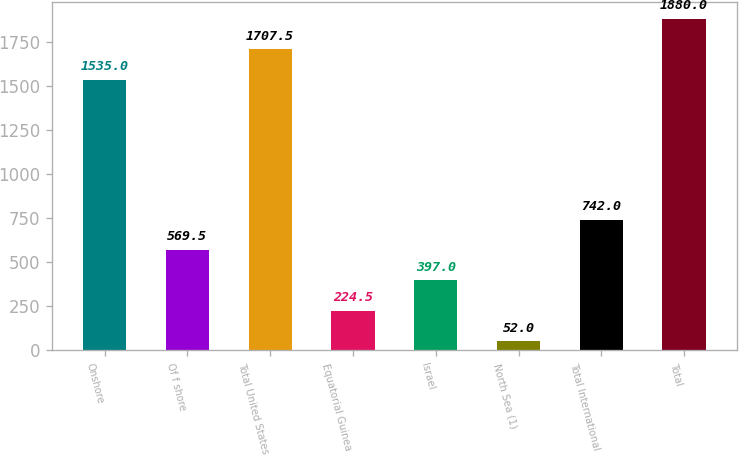Convert chart. <chart><loc_0><loc_0><loc_500><loc_500><bar_chart><fcel>Onshore<fcel>Of f shore<fcel>Total United States<fcel>Equatorial Guinea<fcel>Israel<fcel>North Sea (1)<fcel>Total International<fcel>Total<nl><fcel>1535<fcel>569.5<fcel>1707.5<fcel>224.5<fcel>397<fcel>52<fcel>742<fcel>1880<nl></chart> 